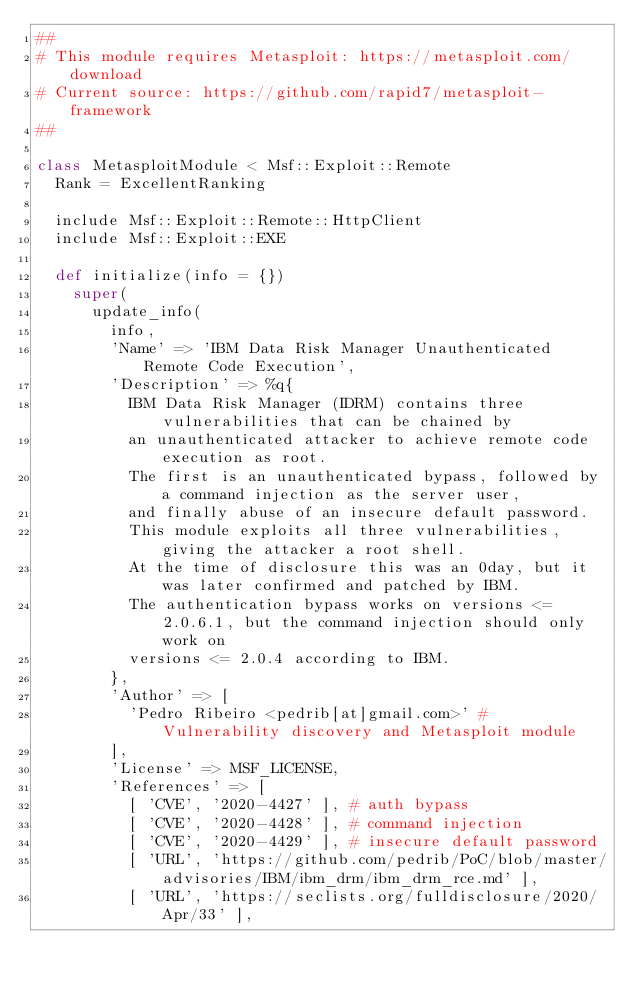<code> <loc_0><loc_0><loc_500><loc_500><_Ruby_>##
# This module requires Metasploit: https://metasploit.com/download
# Current source: https://github.com/rapid7/metasploit-framework
##

class MetasploitModule < Msf::Exploit::Remote
  Rank = ExcellentRanking

  include Msf::Exploit::Remote::HttpClient
  include Msf::Exploit::EXE

  def initialize(info = {})
    super(
      update_info(
        info,
        'Name' => 'IBM Data Risk Manager Unauthenticated Remote Code Execution',
        'Description' => %q{
          IBM Data Risk Manager (IDRM) contains three vulnerabilities that can be chained by
          an unauthenticated attacker to achieve remote code execution as root.
          The first is an unauthenticated bypass, followed by a command injection as the server user,
          and finally abuse of an insecure default password.
          This module exploits all three vulnerabilities, giving the attacker a root shell.
          At the time of disclosure this was an 0day, but it was later confirmed and patched by IBM.
          The authentication bypass works on versions <= 2.0.6.1, but the command injection should only work on
          versions <= 2.0.4 according to IBM.
        },
        'Author' => [
          'Pedro Ribeiro <pedrib[at]gmail.com>' # Vulnerability discovery and Metasploit module
        ],
        'License' => MSF_LICENSE,
        'References' => [
          [ 'CVE', '2020-4427' ], # auth bypass
          [ 'CVE', '2020-4428' ], # command injection
          [ 'CVE', '2020-4429' ], # insecure default password
          [ 'URL', 'https://github.com/pedrib/PoC/blob/master/advisories/IBM/ibm_drm/ibm_drm_rce.md' ],
          [ 'URL', 'https://seclists.org/fulldisclosure/2020/Apr/33' ],</code> 